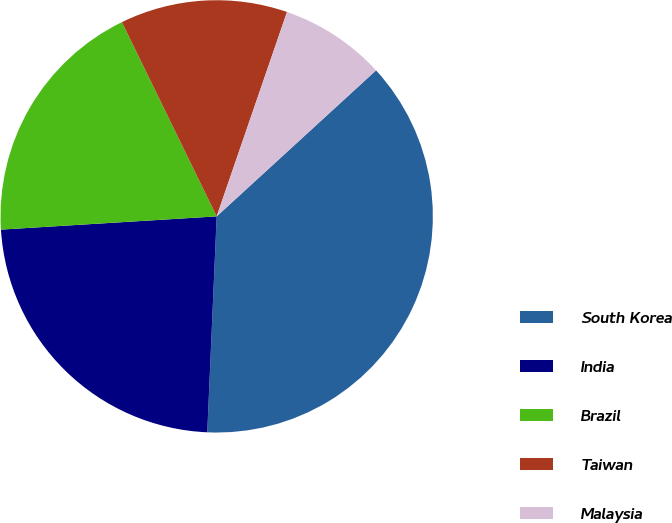<chart> <loc_0><loc_0><loc_500><loc_500><pie_chart><fcel>South Korea<fcel>India<fcel>Brazil<fcel>Taiwan<fcel>Malaysia<nl><fcel>37.5%<fcel>23.33%<fcel>18.75%<fcel>12.5%<fcel>7.92%<nl></chart> 